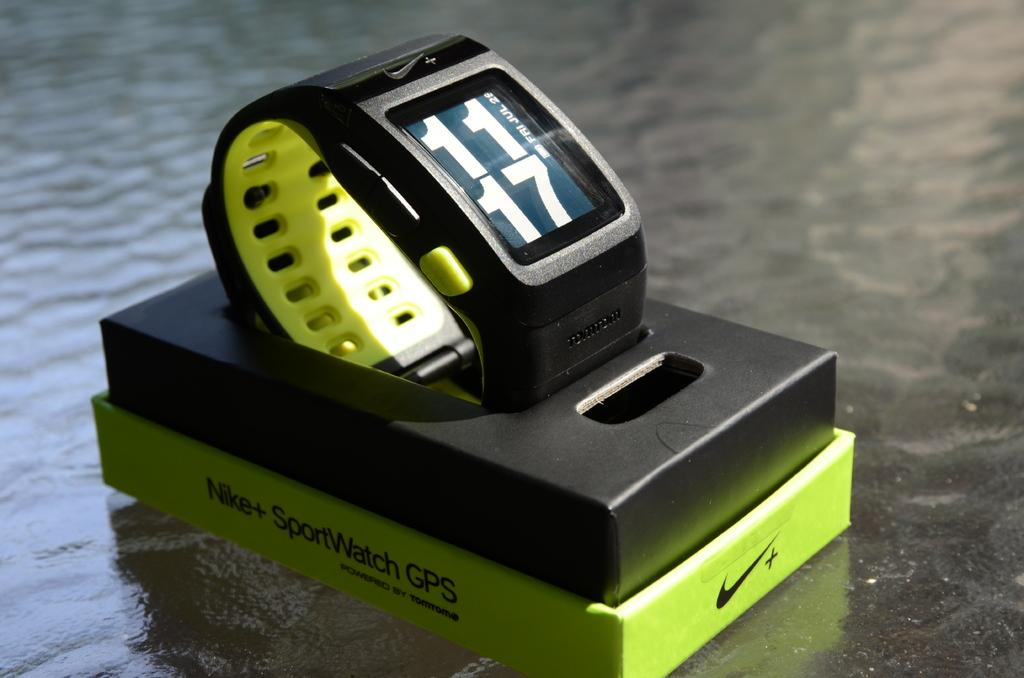Provide a one-sentence caption for the provided image. A Nike+ SportsWatch with GPS is sitting its open packaging. 